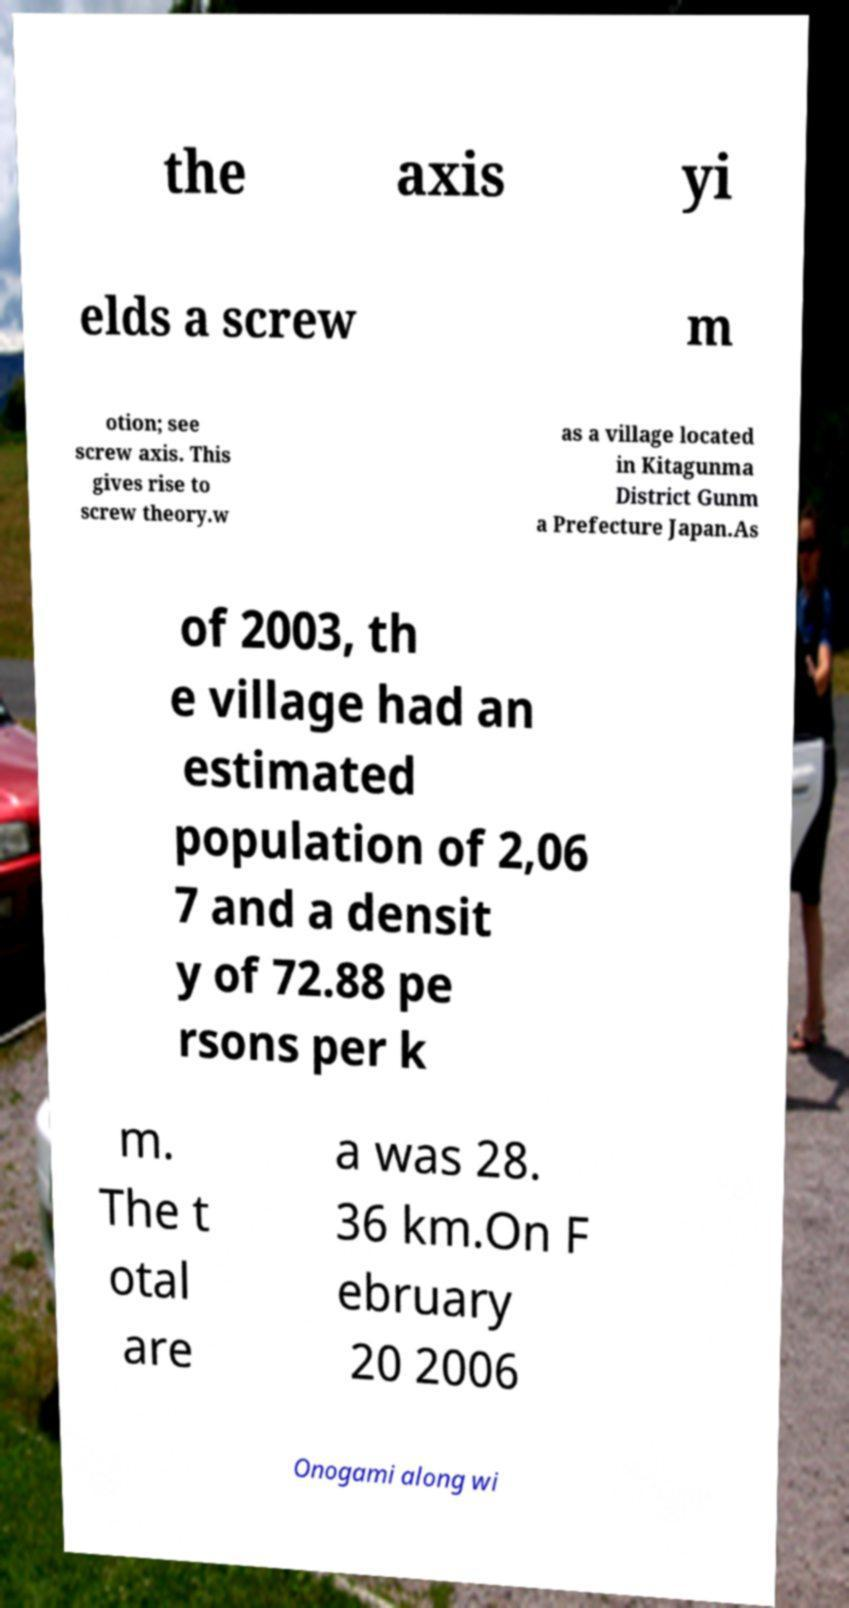I need the written content from this picture converted into text. Can you do that? the axis yi elds a screw m otion; see screw axis. This gives rise to screw theory.w as a village located in Kitagunma District Gunm a Prefecture Japan.As of 2003, th e village had an estimated population of 2,06 7 and a densit y of 72.88 pe rsons per k m. The t otal are a was 28. 36 km.On F ebruary 20 2006 Onogami along wi 